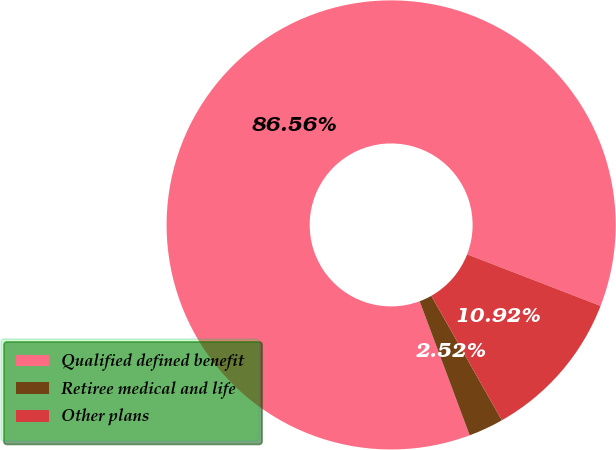<chart> <loc_0><loc_0><loc_500><loc_500><pie_chart><fcel>Qualified defined benefit<fcel>Retiree medical and life<fcel>Other plans<nl><fcel>86.56%<fcel>2.52%<fcel>10.92%<nl></chart> 